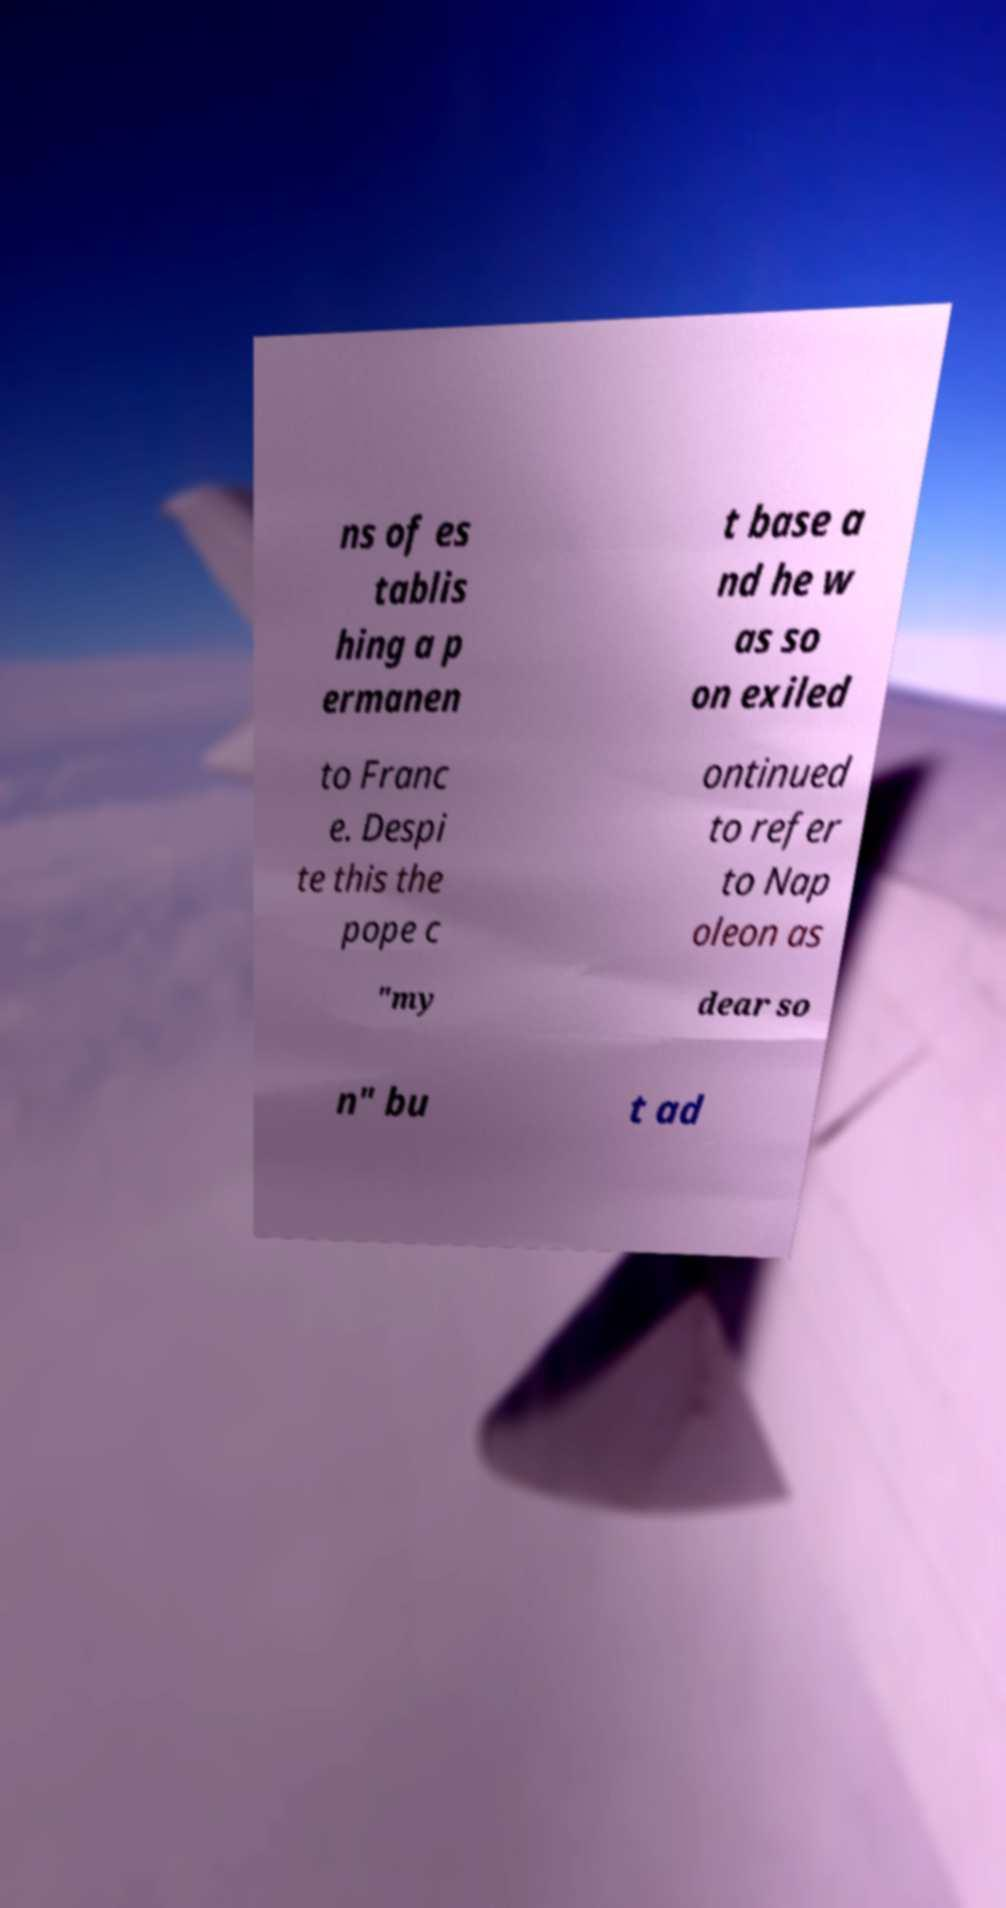I need the written content from this picture converted into text. Can you do that? ns of es tablis hing a p ermanen t base a nd he w as so on exiled to Franc e. Despi te this the pope c ontinued to refer to Nap oleon as "my dear so n" bu t ad 